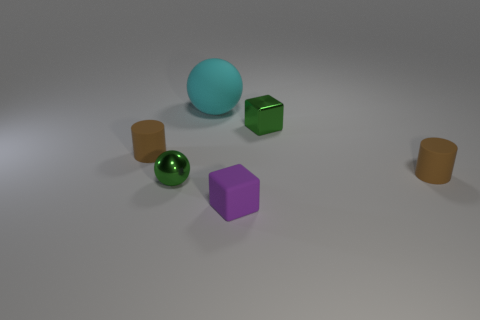There is a rubber block; does it have the same size as the brown matte cylinder to the right of the small ball?
Make the answer very short. Yes. There is a green metallic thing that is behind the small brown cylinder that is left of the green shiny object that is to the right of the big cyan object; what is its size?
Keep it short and to the point. Small. How many things are either tiny brown cylinders that are to the right of the tiny shiny block or tiny purple matte objects?
Provide a short and direct response. 2. There is a brown cylinder that is on the left side of the purple cube; how many small objects are in front of it?
Your answer should be compact. 3. Is the number of things that are left of the purple block greater than the number of tiny brown rubber balls?
Make the answer very short. Yes. What size is the matte thing that is both left of the small purple object and to the right of the metal sphere?
Offer a terse response. Large. The tiny thing that is both behind the green metallic sphere and on the left side of the big cyan sphere has what shape?
Offer a terse response. Cylinder. Is there a small purple rubber thing that is behind the green metal thing that is in front of the tiny brown cylinder to the left of the purple block?
Your response must be concise. No. How many objects are tiny green metal objects that are on the right side of the rubber ball or matte things that are behind the small purple block?
Offer a very short reply. 4. Is the brown cylinder that is to the right of the cyan matte thing made of the same material as the small green block?
Make the answer very short. No. 